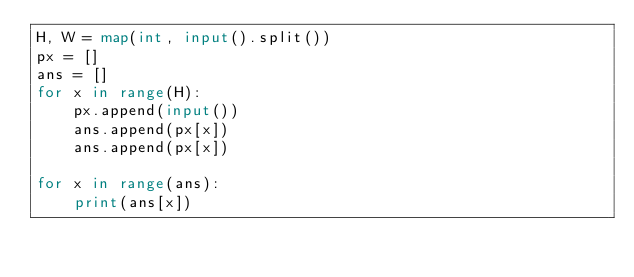Convert code to text. <code><loc_0><loc_0><loc_500><loc_500><_Python_>H, W = map(int, input().split())
px = []
ans = []
for x in range(H):
    px.append(input())
    ans.append(px[x])
    ans.append(px[x])

for x in range(ans):
    print(ans[x])</code> 